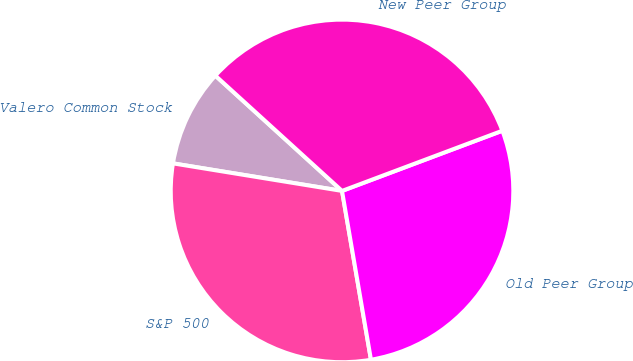Convert chart to OTSL. <chart><loc_0><loc_0><loc_500><loc_500><pie_chart><fcel>Valero Common Stock<fcel>S&P 500<fcel>Old Peer Group<fcel>New Peer Group<nl><fcel>9.18%<fcel>30.27%<fcel>28.01%<fcel>32.53%<nl></chart> 